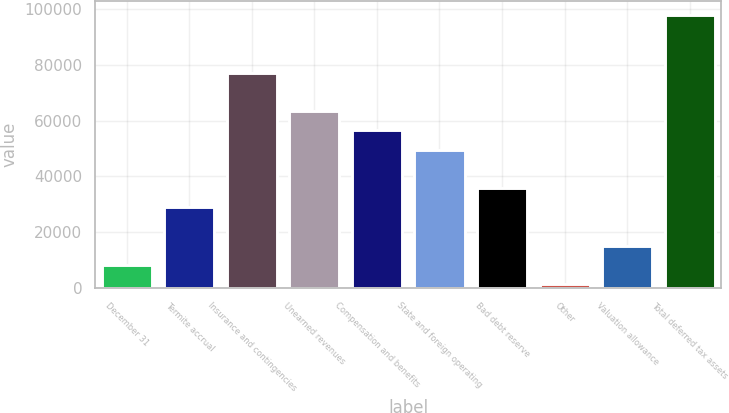<chart> <loc_0><loc_0><loc_500><loc_500><bar_chart><fcel>December 31<fcel>Termite accrual<fcel>Insurance and contingencies<fcel>Unearned revenues<fcel>Compensation and benefits<fcel>State and foreign operating<fcel>Bad debt reserve<fcel>Other<fcel>Valuation allowance<fcel>Total deferred tax assets<nl><fcel>8187.5<fcel>28925<fcel>77312.5<fcel>63487.5<fcel>56575<fcel>49662.5<fcel>35837.5<fcel>1275<fcel>15100<fcel>98050<nl></chart> 